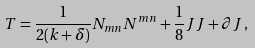Convert formula to latex. <formula><loc_0><loc_0><loc_500><loc_500>T = \frac { 1 } { 2 ( k + \delta ) } N _ { m n } N ^ { m n } + \frac { 1 } { 8 } J J + \partial J \, ,</formula> 